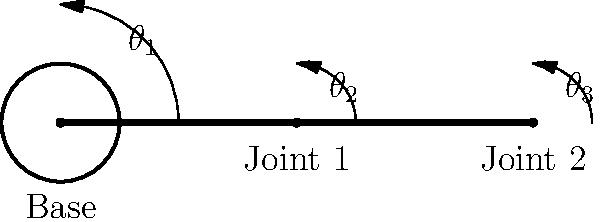A robotic arm with two joints and a base is designed for industrial automation tasks. The arm's movements can be described by rotation angles $\theta_1$, $\theta_2$, and $\theta_3$ as shown in the diagram. If the symmetry group of the arm's possible configurations is isomorphic to the dihedral group $D_4$, what is the maximum number of distinct configurations the arm can achieve? To solve this problem, we need to follow these steps:

1) Recall that the dihedral group $D_4$ represents the symmetries of a regular square. It has 8 elements in total:
   - 4 rotations (0°, 90°, 180°, 270°)
   - 4 reflections (2 diagonal, 2 through midpoints of opposite sides)

2) The isomorphism between the arm's symmetry group and $D_4$ implies that the arm's configurations have the same structure as $D_4$.

3) In the context of the robotic arm:
   - Rotations could correspond to different combinations of joint angles.
   - Reflections could represent configurations that are mirror images of each other.

4) The order (number of elements) of a group is preserved under isomorphism. Therefore, the number of distinct configurations of the arm must be equal to the order of $D_4$.

5) We know that $|D_4| = 8$, where $|D_4|$ denotes the order of $D_4$.

Therefore, the maximum number of distinct configurations the arm can achieve is 8.

This result implies that the arm's control system likely discretizes its movements into 8 principal positions, which could be beneficial for precise, repeatable movements in industrial automation tasks.
Answer: 8 configurations 